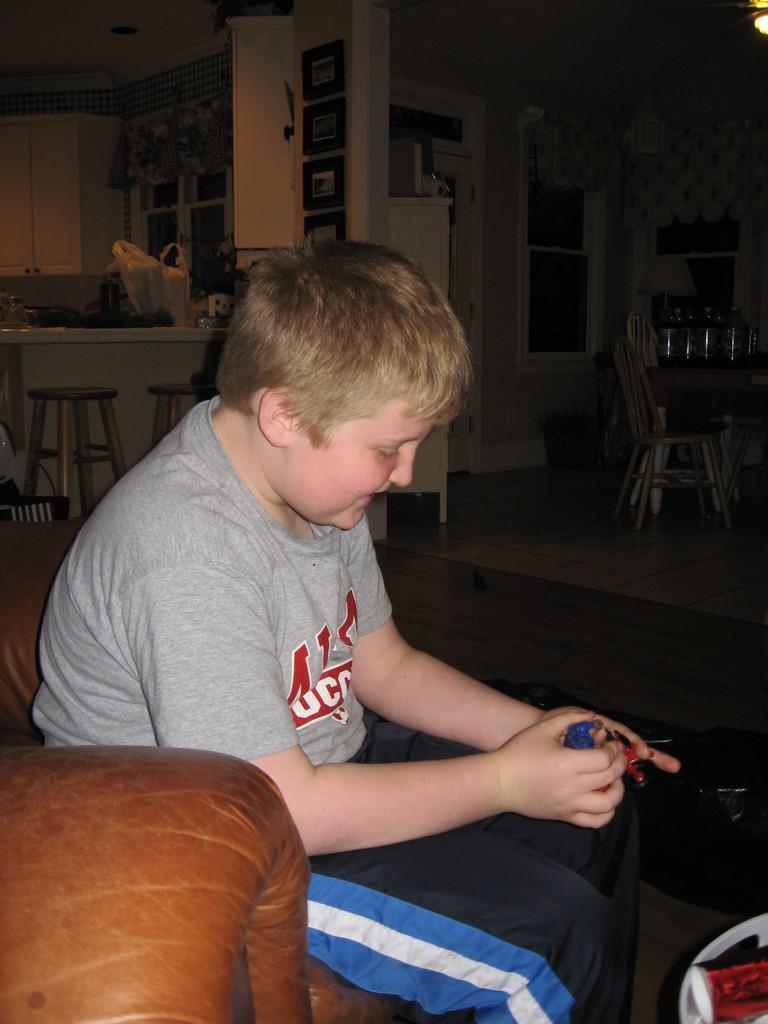Please provide a concise description of this image. This boy is sitting on a couch and holding a toy. At the background we can able to see tables, pictures on wall, window with curtain, cupboards, chairs and bag. On this tables there are things. 